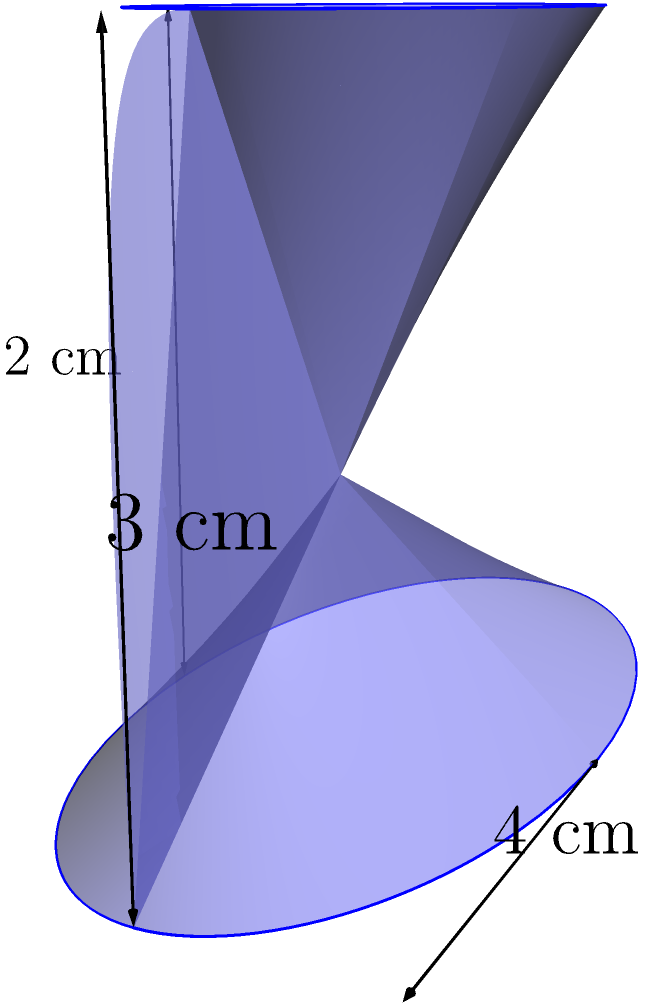As a customer reviewer for your family's innovative product line, you're examining a new uniquely shaped container. The container has an elliptical base that tapers to a smaller elliptical top. The height of the container is 3 cm, the major axis of the base is 4 cm, and the minor axis of the top is 1.5 cm. If the volume of this container is approximately 75% of a cylinder with the same height and base dimensions, what is the estimated volume of the container in cubic centimeters? Let's approach this step-by-step:

1) First, we need to calculate the volume of a cylinder with the same height and base dimensions:
   
   Cylinder volume = $\pi r_1 r_2 h$, where $r_1$ and $r_2$ are the radii of the elliptical base

2) The major axis of the base is 4 cm, so $r_1 = 2$ cm
   The minor axis isn't given, but we can estimate it as half of the major axis, so $r_2 = 1$ cm
   The height $h = 3$ cm

3) Cylinder volume = $\pi \cdot 2 \cdot 1 \cdot 3 = 6\pi$ cubic cm

4) The container's volume is approximately 75% of this cylinder:
   Container volume $\approx 0.75 \cdot 6\pi = 4.5\pi$ cubic cm

5) $4.5\pi \approx 14.14$ cubic cm

Therefore, the estimated volume of the container is approximately 14.14 cubic cm.
Answer: 14.14 cm³ 